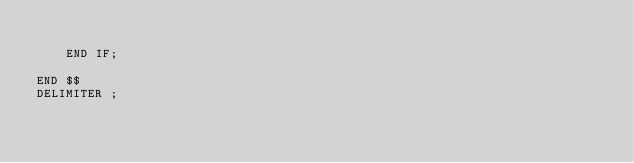Convert code to text. <code><loc_0><loc_0><loc_500><loc_500><_SQL_>        
    END IF;

END $$
DELIMITER ;</code> 